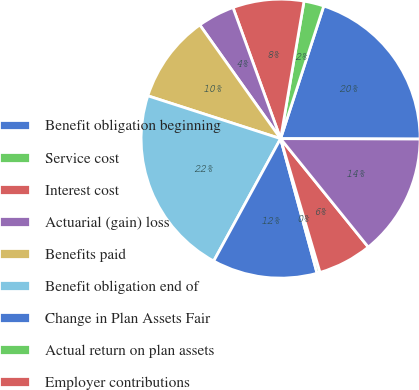Convert chart. <chart><loc_0><loc_0><loc_500><loc_500><pie_chart><fcel>Benefit obligation beginning<fcel>Service cost<fcel>Interest cost<fcel>Actuarial (gain) loss<fcel>Benefits paid<fcel>Benefit obligation end of<fcel>Change in Plan Assets Fair<fcel>Actual return on plan assets<fcel>Employer contributions<fcel>Fair value of assets end of<nl><fcel>20.04%<fcel>2.32%<fcel>8.23%<fcel>4.29%<fcel>10.2%<fcel>22.01%<fcel>12.17%<fcel>0.35%<fcel>6.26%<fcel>14.13%<nl></chart> 